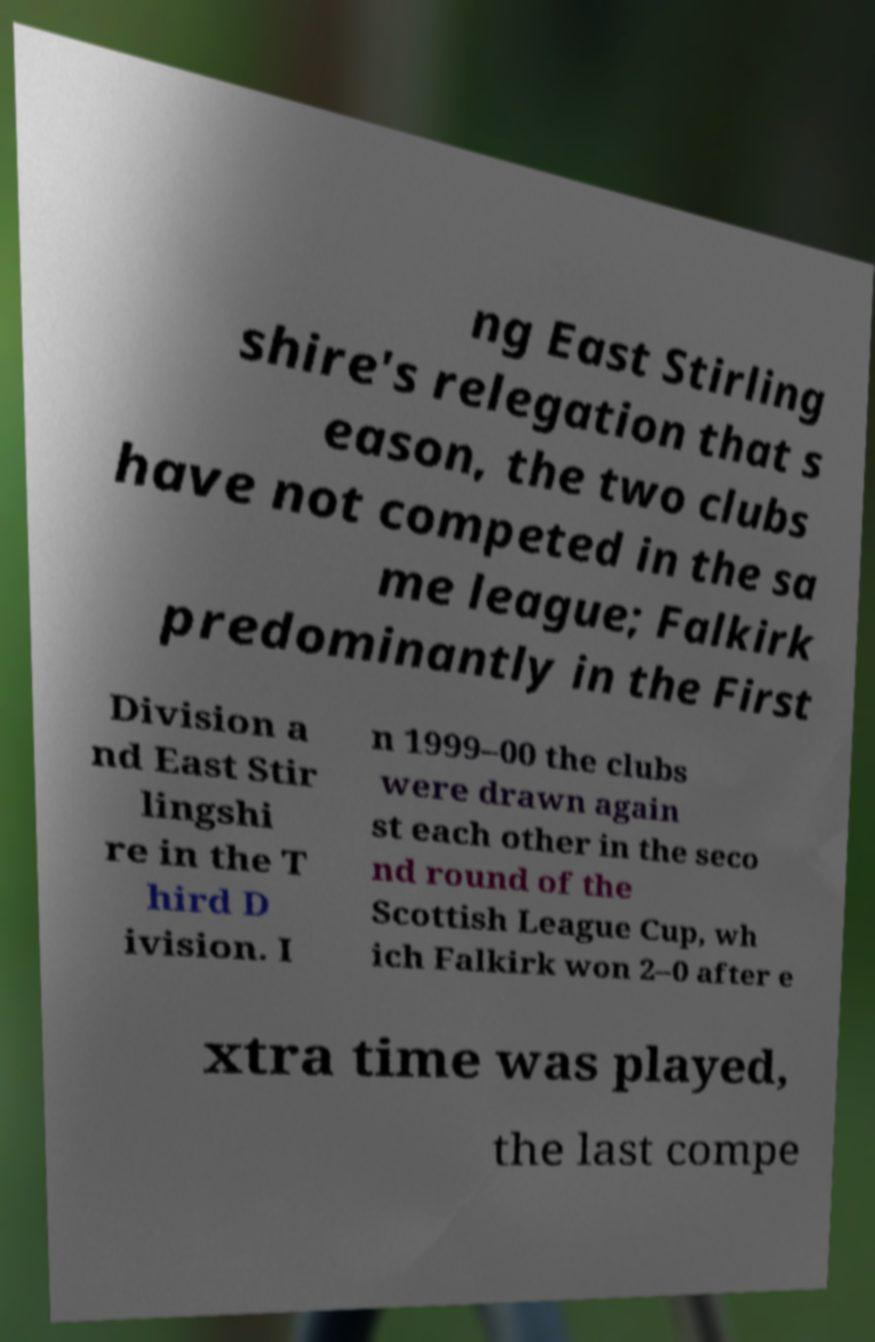Could you assist in decoding the text presented in this image and type it out clearly? ng East Stirling shire's relegation that s eason, the two clubs have not competed in the sa me league; Falkirk predominantly in the First Division a nd East Stir lingshi re in the T hird D ivision. I n 1999–00 the clubs were drawn again st each other in the seco nd round of the Scottish League Cup, wh ich Falkirk won 2–0 after e xtra time was played, the last compe 